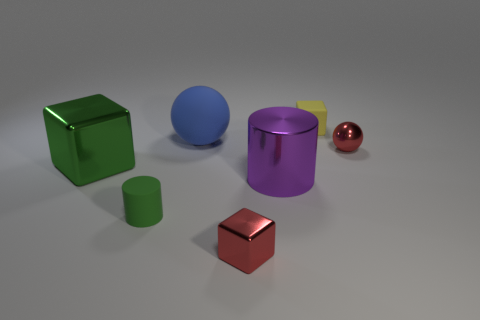Is the number of green things behind the big blue ball the same as the number of large rubber cylinders?
Offer a terse response. Yes. What is the color of the big sphere?
Make the answer very short. Blue. There is a green cube that is made of the same material as the large cylinder; what is its size?
Your response must be concise. Large. The big cylinder that is made of the same material as the small red sphere is what color?
Provide a succinct answer. Purple. Are there any yellow cylinders that have the same size as the green rubber object?
Give a very brief answer. No. There is another object that is the same shape as the purple shiny object; what material is it?
Offer a very short reply. Rubber. There is a blue rubber object that is the same size as the green cube; what is its shape?
Your response must be concise. Sphere. Is there a tiny red metallic object that has the same shape as the tiny yellow thing?
Make the answer very short. Yes. There is a big blue matte thing that is behind the matte object in front of the green cube; what shape is it?
Ensure brevity in your answer.  Sphere. There is a big matte object; what shape is it?
Offer a terse response. Sphere. 